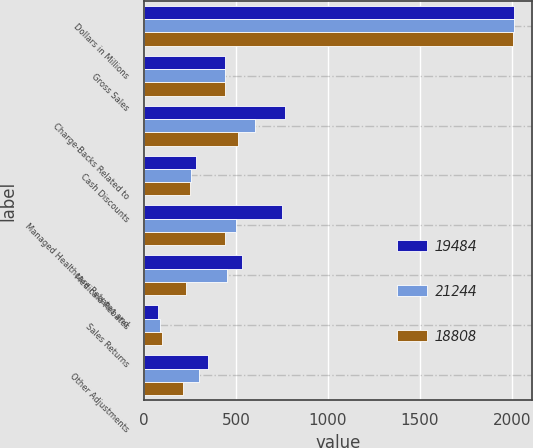<chart> <loc_0><loc_0><loc_500><loc_500><stacked_bar_chart><ecel><fcel>Dollars in Millions<fcel>Gross Sales<fcel>Charge-Backs Related to<fcel>Cash Discounts<fcel>Managed Healthcare Rebates and<fcel>Medicaid Rebates<fcel>Sales Returns<fcel>Other Adjustments<nl><fcel>19484<fcel>2011<fcel>439<fcel>767<fcel>282<fcel>752<fcel>536<fcel>76<fcel>350<nl><fcel>21244<fcel>2010<fcel>439<fcel>605<fcel>255<fcel>499<fcel>453<fcel>88<fcel>297<nl><fcel>18808<fcel>2009<fcel>439<fcel>513<fcel>253<fcel>439<fcel>229<fcel>101<fcel>212<nl></chart> 